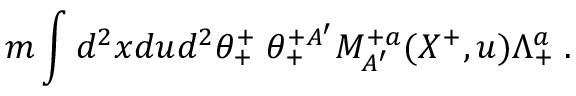Convert formula to latex. <formula><loc_0><loc_0><loc_500><loc_500>m \int d ^ { 2 } x d u d ^ { 2 } \theta _ { + } ^ { + } \, \theta _ { + } ^ { + A ^ { \prime } } M _ { A ^ { \prime } } ^ { + a } ( X ^ { + } , u ) \Lambda _ { + } ^ { a } \, .</formula> 